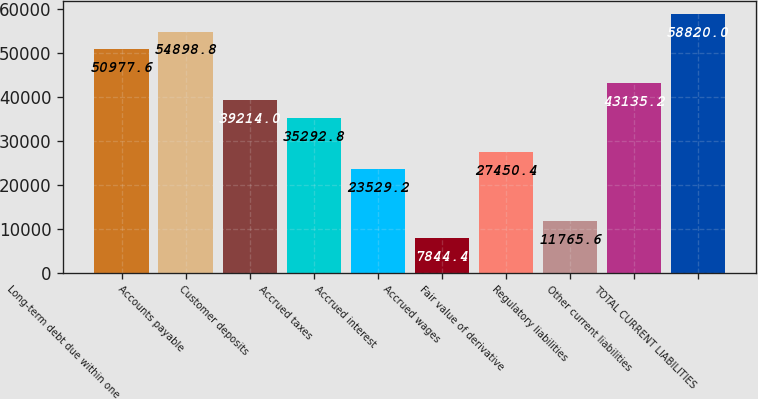Convert chart. <chart><loc_0><loc_0><loc_500><loc_500><bar_chart><fcel>Long-term debt due within one<fcel>Accounts payable<fcel>Customer deposits<fcel>Accrued taxes<fcel>Accrued interest<fcel>Accrued wages<fcel>Fair value of derivative<fcel>Regulatory liabilities<fcel>Other current liabilities<fcel>TOTAL CURRENT LIABILITIES<nl><fcel>50977.6<fcel>54898.8<fcel>39214<fcel>35292.8<fcel>23529.2<fcel>7844.4<fcel>27450.4<fcel>11765.6<fcel>43135.2<fcel>58820<nl></chart> 